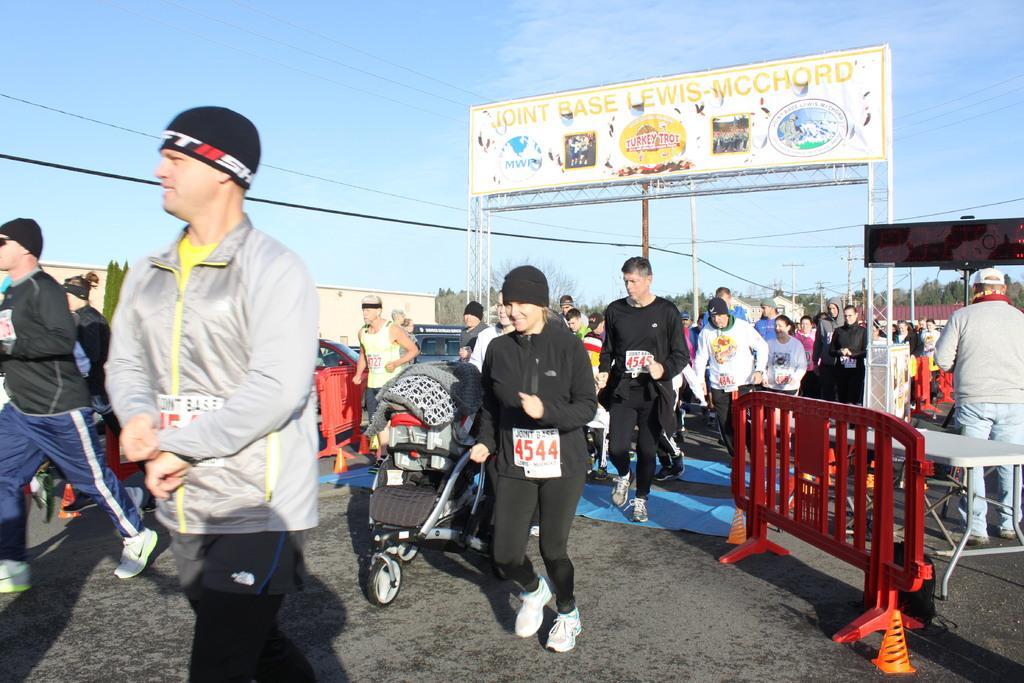In one or two sentences, can you explain what this image depicts? In the middle a beautiful girl is walking, she wore a black color dress. In the left side a man is walking, he wore a coat. In the right side there is an entrance board. At the top it's a cloudy sky. 